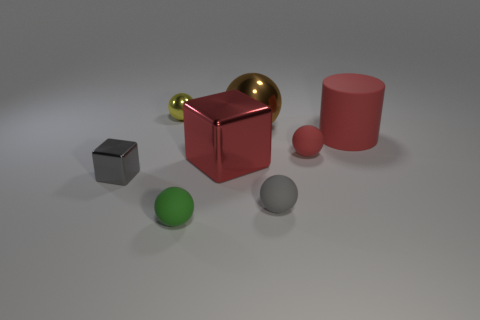How big is the cube that is to the right of the small gray thing to the left of the yellow metallic sphere behind the red shiny object?
Make the answer very short. Large. What material is the small gray ball?
Offer a terse response. Rubber. Is the big ball made of the same material as the red object in front of the small red rubber sphere?
Offer a very short reply. Yes. Is there any other thing of the same color as the matte cylinder?
Provide a short and direct response. Yes. Is there a large brown sphere in front of the metal block that is behind the gray thing left of the large brown ball?
Keep it short and to the point. No. What is the color of the big cylinder?
Your answer should be compact. Red. Are there any gray things on the left side of the large brown shiny thing?
Keep it short and to the point. Yes. There is a large red metallic object; is its shape the same as the gray thing behind the small gray rubber thing?
Offer a very short reply. Yes. How many other objects are there of the same material as the small block?
Offer a terse response. 3. What is the color of the small shiny thing behind the large rubber cylinder that is behind the matte sphere that is on the left side of the big brown thing?
Offer a very short reply. Yellow. 